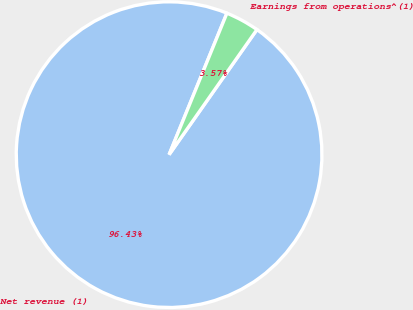Convert chart. <chart><loc_0><loc_0><loc_500><loc_500><pie_chart><fcel>Net revenue (1)<fcel>Earnings from operations^(1)<nl><fcel>96.43%<fcel>3.57%<nl></chart> 